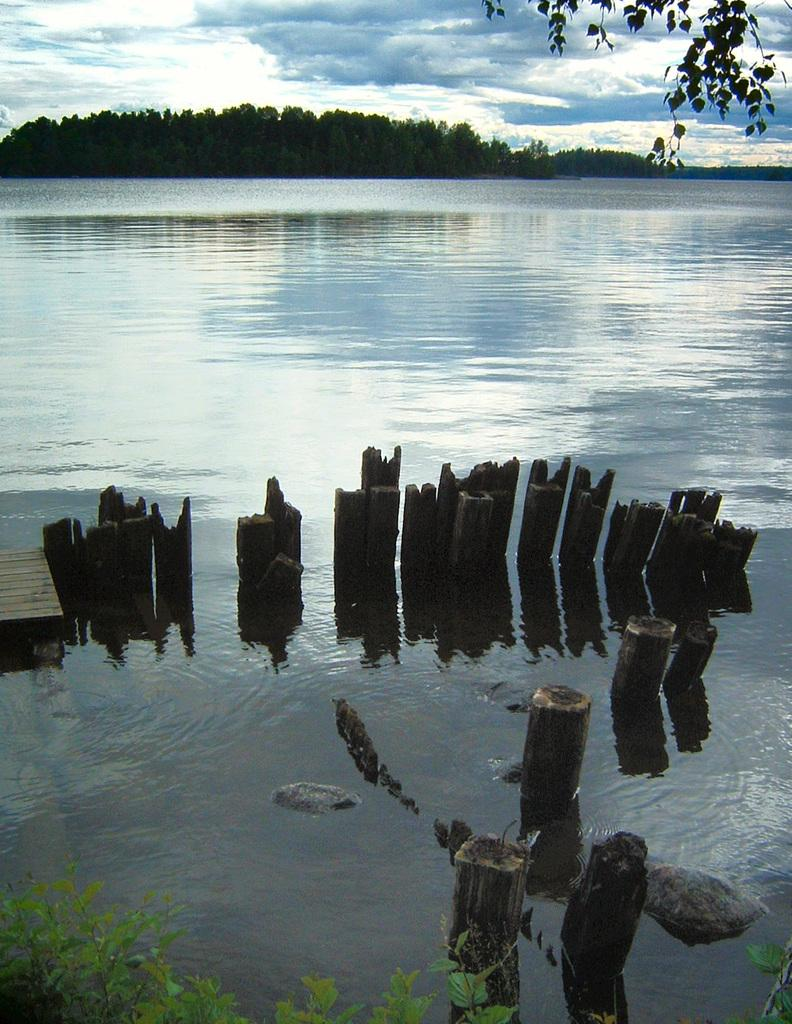What body of water is present in the image? There is a lake in the image. What structure can be seen in the lake? There is a wooden bridge in the lake. What type of vegetation is visible in the background of the image? There are trees in the background of the image. What part of the natural environment is visible in the background of the image? The sky is visible in the background of the image. What type of waves can be seen in the image? There are no waves present in the image, as it features a lake with a wooden bridge and trees in the background. 